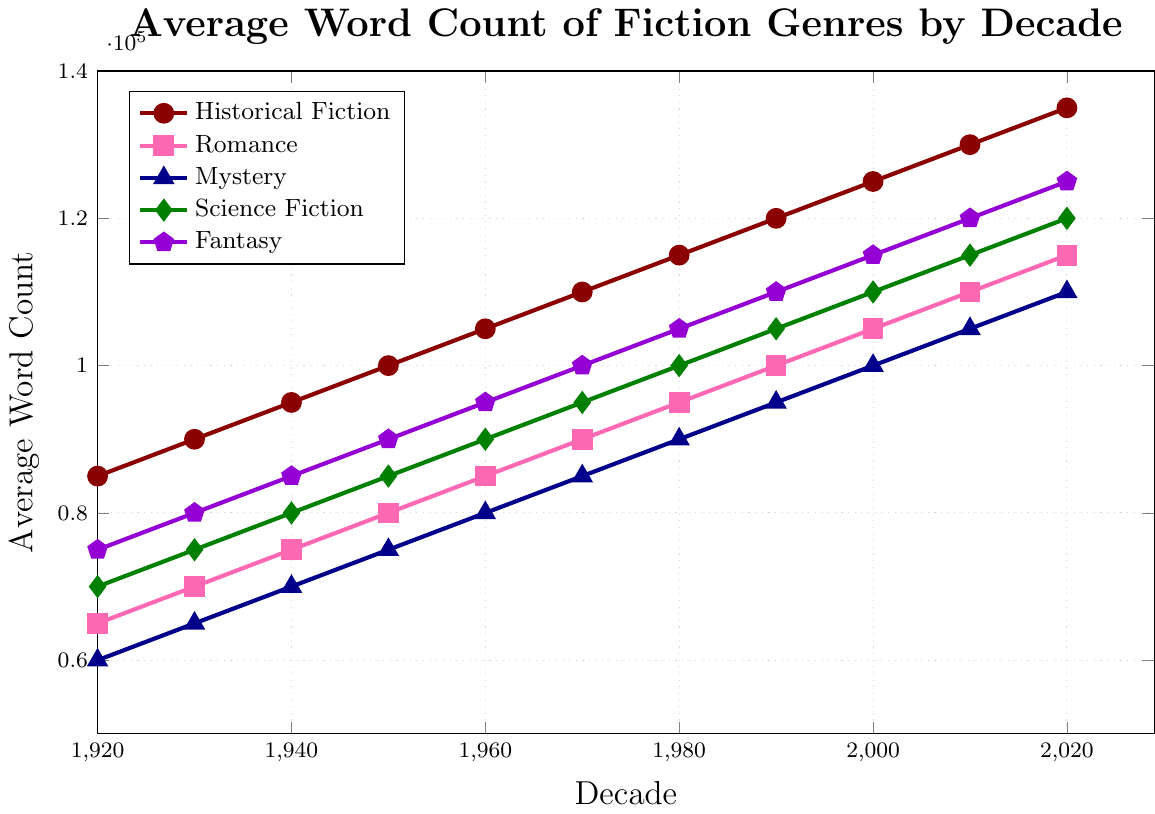Which genre had the highest average word count in the 1950s? By examining the lines on the chart for the 1950s, we see that Historical Fiction reached 100,000 words, which is higher than any other genre.
Answer: Historical Fiction Between the 1920s and 2020s, what is the total increase in average word count for Historical Fiction? The average word count for Historical Fiction in the 1920s is 85,000, and in the 2020s, it is 135,000. The total increase is 135,000 - 85,000 = 50,000 words.
Answer: 50,000 words In which decade did Science Fiction surpass Mystery in average word count? By comparing the lines for Science Fiction and Mystery, we see that Science Fiction surpasses Mystery in the 1950s when Science Fiction reaches 85,000 words, while Mystery is at 75,000 words.
Answer: 1950s Which genre has the steepest growth in average word count from the 1920s to the 1960s? By assessing the slopes of the lines from the 1920s to the 1960s, Historical Fiction shows the steepest increase. From 85,000 to 105,000, it grows by 20,000 words compared to lesser increases in other genres.
Answer: Historical Fiction How much did the average word count of Fantasy novels grow from the 1980s to the 2020s? Fantasy has a word count of 105,000 in the 1980s and grows to 125,000 by the 2020s. The increase is 125,000 - 105,000 = 20,000 words.
Answer: 20,000 words In which decade did Romance novels first surpass a 100,000 average word count? Looking at the Romance line, it surpasses 100,000 words in the 1990s.
Answer: 1990s Which genre had the smallest increase in average word count from the 1920s to the 2020s? By assessing the overall increases for each genre, Mystery grew from 60,000 to 110,000 words, which is an increase of 50,000 words. No other genre has a smaller increase.
Answer: Mystery What is the difference in average word count between Historical Fiction and Fantasy in the 2010s? The word count for Historical Fiction in the 2010s is 130,000, and for Fantasy, it is 120,000. The difference is 130,000 - 120,000 = 10,000 words.
Answer: 10,000 words Which decade shows the most significant jump in average word count for Mystery novels? By looking at the Mystery line, the most significant increase occurs between the 1950s and 1960s, where it jumps from 75,000 to 80,000 words.
Answer: 1960s 